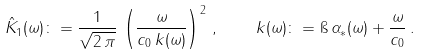Convert formula to latex. <formula><loc_0><loc_0><loc_500><loc_500>\hat { K } _ { 1 } ( \omega ) \colon = \frac { 1 } { \sqrt { 2 \, \pi } } \, \left ( \frac { \omega } { c _ { 0 } \, k ( \omega ) } \right ) ^ { 2 } \, , \quad k ( \omega ) \colon = \i \, \alpha _ { * } ( \omega ) + \frac { \omega } { c _ { 0 } } \, .</formula> 